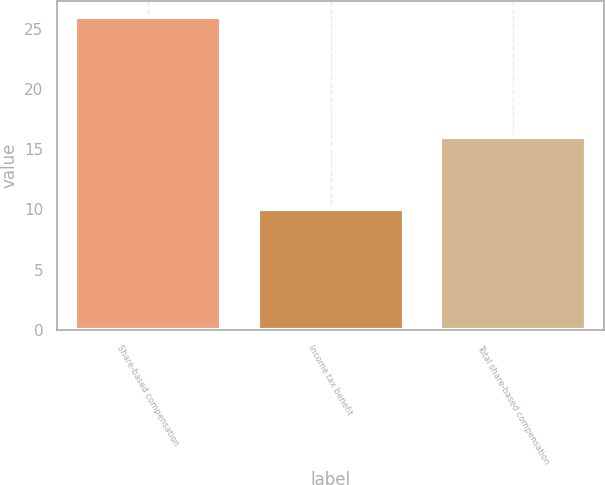Convert chart. <chart><loc_0><loc_0><loc_500><loc_500><bar_chart><fcel>Share-based compensation<fcel>Income tax benefit<fcel>Total share-based compensation<nl><fcel>26<fcel>10<fcel>16<nl></chart> 